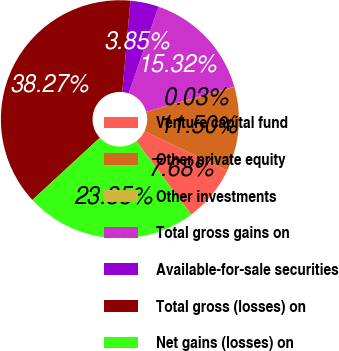Convert chart. <chart><loc_0><loc_0><loc_500><loc_500><pie_chart><fcel>Venture capital fund<fcel>Other private equity<fcel>Other investments<fcel>Total gross gains on<fcel>Available-for-sale securities<fcel>Total gross (losses) on<fcel>Net gains (losses) on<nl><fcel>7.68%<fcel>11.5%<fcel>0.03%<fcel>15.32%<fcel>3.85%<fcel>38.27%<fcel>23.35%<nl></chart> 